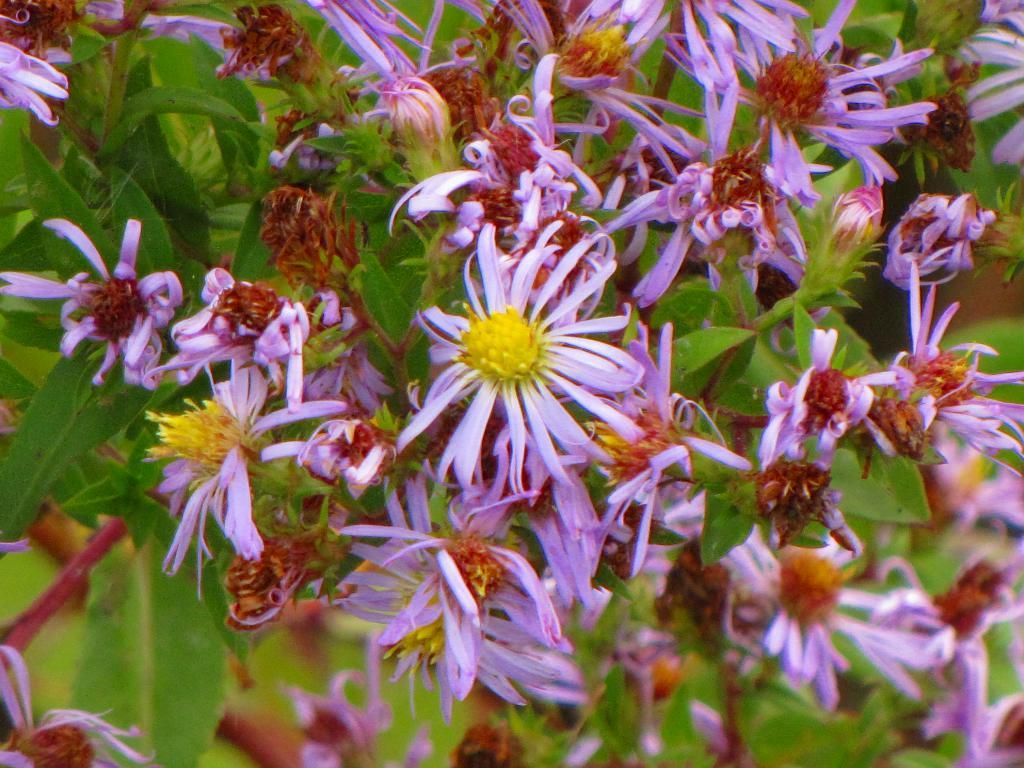What colors of flowers can be seen in the image? There are purple, yellow, and brown flowers in the image. What is the background of the image composed of? The background of the image includes green leaves. How many pigs are visible in the image? There are no pigs present in the image; it features flowers and green leaves. What type of jar is holding the flowers in the image? There is no jar present in the image; the flowers are not contained in any jar. 